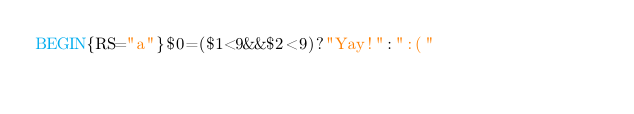Convert code to text. <code><loc_0><loc_0><loc_500><loc_500><_Awk_>BEGIN{RS="a"}$0=($1<9&&$2<9)?"Yay!":":("</code> 